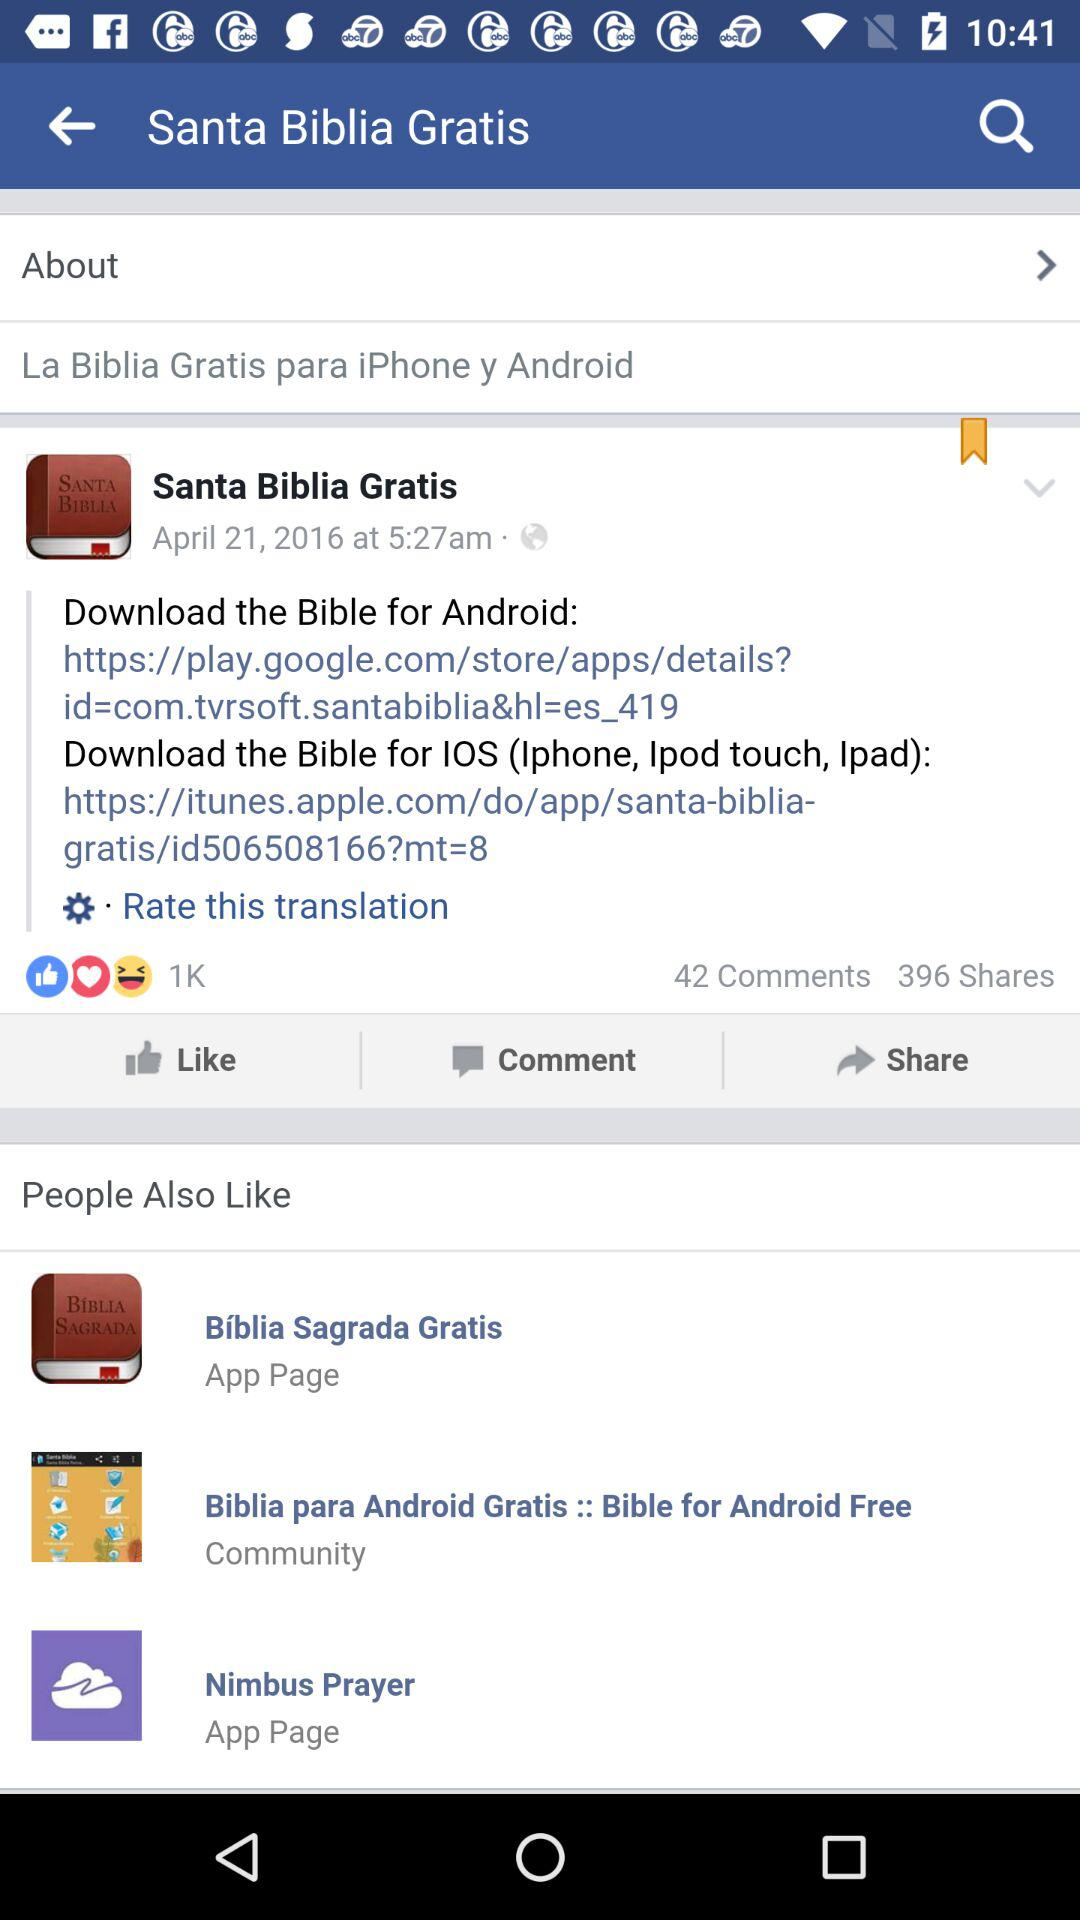How many people have commented on the post? There are 42 people who have commented on the post. 